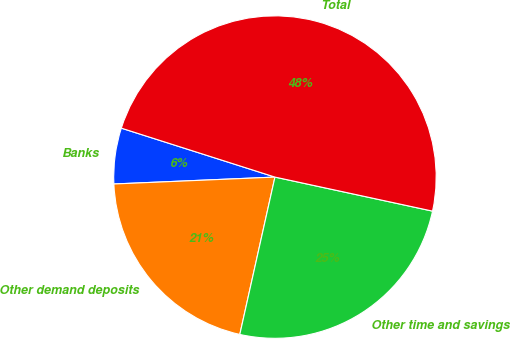Convert chart. <chart><loc_0><loc_0><loc_500><loc_500><pie_chart><fcel>Banks<fcel>Other demand deposits<fcel>Other time and savings<fcel>Total<nl><fcel>5.59%<fcel>20.82%<fcel>25.11%<fcel>48.48%<nl></chart> 